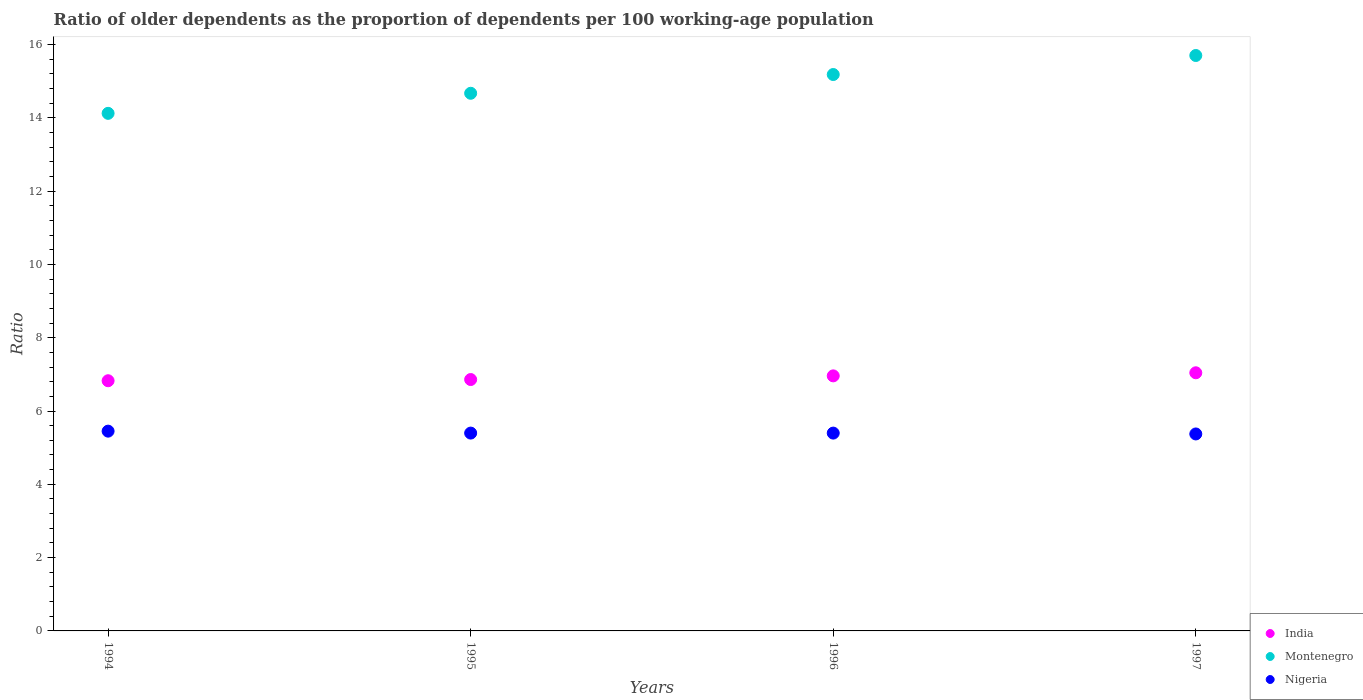What is the age dependency ratio(old) in Nigeria in 1997?
Your answer should be compact. 5.37. Across all years, what is the maximum age dependency ratio(old) in Montenegro?
Offer a terse response. 15.7. Across all years, what is the minimum age dependency ratio(old) in Nigeria?
Offer a very short reply. 5.37. In which year was the age dependency ratio(old) in India maximum?
Offer a very short reply. 1997. In which year was the age dependency ratio(old) in Nigeria minimum?
Offer a terse response. 1997. What is the total age dependency ratio(old) in Nigeria in the graph?
Your answer should be compact. 21.62. What is the difference between the age dependency ratio(old) in Montenegro in 1995 and that in 1997?
Give a very brief answer. -1.03. What is the difference between the age dependency ratio(old) in India in 1997 and the age dependency ratio(old) in Montenegro in 1996?
Provide a short and direct response. -8.14. What is the average age dependency ratio(old) in Nigeria per year?
Provide a succinct answer. 5.41. In the year 1995, what is the difference between the age dependency ratio(old) in India and age dependency ratio(old) in Montenegro?
Your answer should be very brief. -7.81. In how many years, is the age dependency ratio(old) in India greater than 2.4?
Ensure brevity in your answer.  4. What is the ratio of the age dependency ratio(old) in India in 1994 to that in 1997?
Make the answer very short. 0.97. Is the age dependency ratio(old) in Nigeria in 1995 less than that in 1996?
Provide a short and direct response. No. Is the difference between the age dependency ratio(old) in India in 1994 and 1995 greater than the difference between the age dependency ratio(old) in Montenegro in 1994 and 1995?
Give a very brief answer. Yes. What is the difference between the highest and the second highest age dependency ratio(old) in Montenegro?
Give a very brief answer. 0.52. What is the difference between the highest and the lowest age dependency ratio(old) in Montenegro?
Give a very brief answer. 1.58. Is it the case that in every year, the sum of the age dependency ratio(old) in Montenegro and age dependency ratio(old) in Nigeria  is greater than the age dependency ratio(old) in India?
Provide a short and direct response. Yes. How many dotlines are there?
Provide a succinct answer. 3. How many years are there in the graph?
Offer a very short reply. 4. What is the difference between two consecutive major ticks on the Y-axis?
Your answer should be very brief. 2. Are the values on the major ticks of Y-axis written in scientific E-notation?
Provide a succinct answer. No. Does the graph contain any zero values?
Ensure brevity in your answer.  No. How many legend labels are there?
Give a very brief answer. 3. How are the legend labels stacked?
Your answer should be compact. Vertical. What is the title of the graph?
Your answer should be very brief. Ratio of older dependents as the proportion of dependents per 100 working-age population. Does "Congo (Republic)" appear as one of the legend labels in the graph?
Offer a terse response. No. What is the label or title of the Y-axis?
Make the answer very short. Ratio. What is the Ratio in India in 1994?
Provide a short and direct response. 6.83. What is the Ratio of Montenegro in 1994?
Your answer should be compact. 14.12. What is the Ratio in Nigeria in 1994?
Provide a short and direct response. 5.45. What is the Ratio of India in 1995?
Keep it short and to the point. 6.86. What is the Ratio in Montenegro in 1995?
Your response must be concise. 14.67. What is the Ratio of Nigeria in 1995?
Ensure brevity in your answer.  5.4. What is the Ratio of India in 1996?
Your answer should be compact. 6.96. What is the Ratio of Montenegro in 1996?
Ensure brevity in your answer.  15.18. What is the Ratio in Nigeria in 1996?
Provide a short and direct response. 5.4. What is the Ratio in India in 1997?
Give a very brief answer. 7.04. What is the Ratio of Montenegro in 1997?
Ensure brevity in your answer.  15.7. What is the Ratio of Nigeria in 1997?
Provide a short and direct response. 5.37. Across all years, what is the maximum Ratio in India?
Your response must be concise. 7.04. Across all years, what is the maximum Ratio of Montenegro?
Offer a very short reply. 15.7. Across all years, what is the maximum Ratio of Nigeria?
Give a very brief answer. 5.45. Across all years, what is the minimum Ratio of India?
Offer a terse response. 6.83. Across all years, what is the minimum Ratio of Montenegro?
Ensure brevity in your answer.  14.12. Across all years, what is the minimum Ratio of Nigeria?
Provide a succinct answer. 5.37. What is the total Ratio of India in the graph?
Make the answer very short. 27.69. What is the total Ratio of Montenegro in the graph?
Offer a terse response. 59.67. What is the total Ratio of Nigeria in the graph?
Give a very brief answer. 21.62. What is the difference between the Ratio of India in 1994 and that in 1995?
Your answer should be compact. -0.03. What is the difference between the Ratio of Montenegro in 1994 and that in 1995?
Make the answer very short. -0.55. What is the difference between the Ratio of Nigeria in 1994 and that in 1995?
Give a very brief answer. 0.05. What is the difference between the Ratio of India in 1994 and that in 1996?
Keep it short and to the point. -0.13. What is the difference between the Ratio in Montenegro in 1994 and that in 1996?
Give a very brief answer. -1.06. What is the difference between the Ratio of Nigeria in 1994 and that in 1996?
Provide a short and direct response. 0.05. What is the difference between the Ratio of India in 1994 and that in 1997?
Make the answer very short. -0.22. What is the difference between the Ratio in Montenegro in 1994 and that in 1997?
Offer a terse response. -1.58. What is the difference between the Ratio in Nigeria in 1994 and that in 1997?
Offer a very short reply. 0.08. What is the difference between the Ratio in Montenegro in 1995 and that in 1996?
Ensure brevity in your answer.  -0.51. What is the difference between the Ratio in India in 1995 and that in 1997?
Provide a succinct answer. -0.18. What is the difference between the Ratio of Montenegro in 1995 and that in 1997?
Your answer should be compact. -1.03. What is the difference between the Ratio in Nigeria in 1995 and that in 1997?
Offer a terse response. 0.02. What is the difference between the Ratio of India in 1996 and that in 1997?
Ensure brevity in your answer.  -0.08. What is the difference between the Ratio in Montenegro in 1996 and that in 1997?
Your answer should be very brief. -0.52. What is the difference between the Ratio of Nigeria in 1996 and that in 1997?
Offer a terse response. 0.02. What is the difference between the Ratio of India in 1994 and the Ratio of Montenegro in 1995?
Offer a terse response. -7.84. What is the difference between the Ratio in India in 1994 and the Ratio in Nigeria in 1995?
Offer a very short reply. 1.43. What is the difference between the Ratio in Montenegro in 1994 and the Ratio in Nigeria in 1995?
Keep it short and to the point. 8.72. What is the difference between the Ratio of India in 1994 and the Ratio of Montenegro in 1996?
Make the answer very short. -8.35. What is the difference between the Ratio in India in 1994 and the Ratio in Nigeria in 1996?
Give a very brief answer. 1.43. What is the difference between the Ratio of Montenegro in 1994 and the Ratio of Nigeria in 1996?
Offer a terse response. 8.72. What is the difference between the Ratio of India in 1994 and the Ratio of Montenegro in 1997?
Provide a short and direct response. -8.87. What is the difference between the Ratio in India in 1994 and the Ratio in Nigeria in 1997?
Offer a terse response. 1.45. What is the difference between the Ratio in Montenegro in 1994 and the Ratio in Nigeria in 1997?
Give a very brief answer. 8.75. What is the difference between the Ratio in India in 1995 and the Ratio in Montenegro in 1996?
Ensure brevity in your answer.  -8.32. What is the difference between the Ratio of India in 1995 and the Ratio of Nigeria in 1996?
Ensure brevity in your answer.  1.46. What is the difference between the Ratio of Montenegro in 1995 and the Ratio of Nigeria in 1996?
Provide a succinct answer. 9.27. What is the difference between the Ratio of India in 1995 and the Ratio of Montenegro in 1997?
Keep it short and to the point. -8.84. What is the difference between the Ratio of India in 1995 and the Ratio of Nigeria in 1997?
Ensure brevity in your answer.  1.48. What is the difference between the Ratio in Montenegro in 1995 and the Ratio in Nigeria in 1997?
Your answer should be compact. 9.3. What is the difference between the Ratio of India in 1996 and the Ratio of Montenegro in 1997?
Ensure brevity in your answer.  -8.74. What is the difference between the Ratio of India in 1996 and the Ratio of Nigeria in 1997?
Keep it short and to the point. 1.58. What is the difference between the Ratio in Montenegro in 1996 and the Ratio in Nigeria in 1997?
Your answer should be compact. 9.81. What is the average Ratio of India per year?
Provide a short and direct response. 6.92. What is the average Ratio of Montenegro per year?
Your answer should be compact. 14.92. What is the average Ratio in Nigeria per year?
Offer a very short reply. 5.41. In the year 1994, what is the difference between the Ratio of India and Ratio of Montenegro?
Ensure brevity in your answer.  -7.3. In the year 1994, what is the difference between the Ratio in India and Ratio in Nigeria?
Your response must be concise. 1.38. In the year 1994, what is the difference between the Ratio of Montenegro and Ratio of Nigeria?
Make the answer very short. 8.67. In the year 1995, what is the difference between the Ratio in India and Ratio in Montenegro?
Offer a terse response. -7.81. In the year 1995, what is the difference between the Ratio of India and Ratio of Nigeria?
Ensure brevity in your answer.  1.46. In the year 1995, what is the difference between the Ratio in Montenegro and Ratio in Nigeria?
Ensure brevity in your answer.  9.27. In the year 1996, what is the difference between the Ratio in India and Ratio in Montenegro?
Your answer should be very brief. -8.22. In the year 1996, what is the difference between the Ratio in India and Ratio in Nigeria?
Ensure brevity in your answer.  1.56. In the year 1996, what is the difference between the Ratio in Montenegro and Ratio in Nigeria?
Provide a succinct answer. 9.78. In the year 1997, what is the difference between the Ratio of India and Ratio of Montenegro?
Give a very brief answer. -8.66. In the year 1997, what is the difference between the Ratio in India and Ratio in Nigeria?
Provide a succinct answer. 1.67. In the year 1997, what is the difference between the Ratio of Montenegro and Ratio of Nigeria?
Ensure brevity in your answer.  10.33. What is the ratio of the Ratio in India in 1994 to that in 1995?
Offer a terse response. 1. What is the ratio of the Ratio in Montenegro in 1994 to that in 1995?
Your response must be concise. 0.96. What is the ratio of the Ratio in Nigeria in 1994 to that in 1995?
Make the answer very short. 1.01. What is the ratio of the Ratio of India in 1994 to that in 1996?
Your answer should be very brief. 0.98. What is the ratio of the Ratio in Montenegro in 1994 to that in 1996?
Offer a terse response. 0.93. What is the ratio of the Ratio of Nigeria in 1994 to that in 1996?
Your response must be concise. 1.01. What is the ratio of the Ratio in India in 1994 to that in 1997?
Your response must be concise. 0.97. What is the ratio of the Ratio of Montenegro in 1994 to that in 1997?
Your answer should be compact. 0.9. What is the ratio of the Ratio in Nigeria in 1994 to that in 1997?
Offer a very short reply. 1.01. What is the ratio of the Ratio of India in 1995 to that in 1996?
Your answer should be very brief. 0.99. What is the ratio of the Ratio in Montenegro in 1995 to that in 1996?
Provide a succinct answer. 0.97. What is the ratio of the Ratio in Nigeria in 1995 to that in 1996?
Make the answer very short. 1. What is the ratio of the Ratio in India in 1995 to that in 1997?
Ensure brevity in your answer.  0.97. What is the ratio of the Ratio in Montenegro in 1995 to that in 1997?
Provide a short and direct response. 0.93. What is the ratio of the Ratio of Nigeria in 1995 to that in 1997?
Provide a succinct answer. 1. What is the ratio of the Ratio of Montenegro in 1996 to that in 1997?
Your response must be concise. 0.97. What is the difference between the highest and the second highest Ratio of India?
Provide a short and direct response. 0.08. What is the difference between the highest and the second highest Ratio of Montenegro?
Ensure brevity in your answer.  0.52. What is the difference between the highest and the second highest Ratio in Nigeria?
Offer a terse response. 0.05. What is the difference between the highest and the lowest Ratio of India?
Your answer should be compact. 0.22. What is the difference between the highest and the lowest Ratio in Montenegro?
Your answer should be very brief. 1.58. What is the difference between the highest and the lowest Ratio in Nigeria?
Provide a succinct answer. 0.08. 